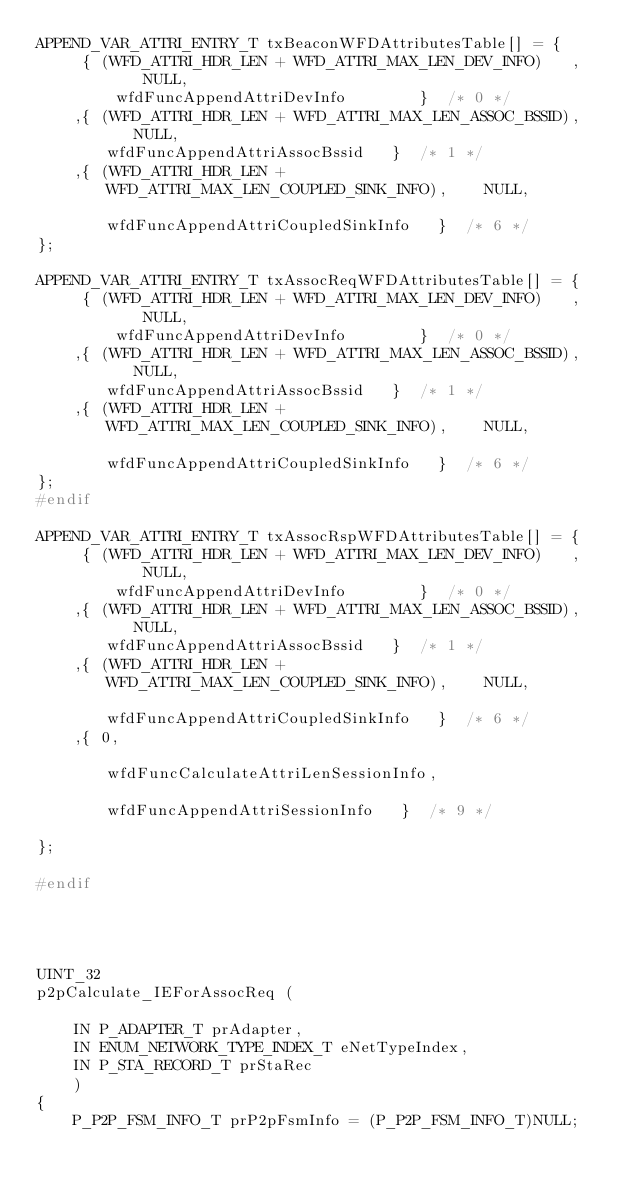<code> <loc_0><loc_0><loc_500><loc_500><_C_>APPEND_VAR_ATTRI_ENTRY_T txBeaconWFDAttributesTable[] = {
     { (WFD_ATTRI_HDR_LEN + WFD_ATTRI_MAX_LEN_DEV_INFO)   ,    NULL,                           wfdFuncAppendAttriDevInfo        }  /* 0 */
    ,{ (WFD_ATTRI_HDR_LEN + WFD_ATTRI_MAX_LEN_ASSOC_BSSID),    NULL,                           wfdFuncAppendAttriAssocBssid   }  /* 1 */
    ,{ (WFD_ATTRI_HDR_LEN + WFD_ATTRI_MAX_LEN_COUPLED_SINK_INFO),    NULL,                           wfdFuncAppendAttriCoupledSinkInfo   }  /* 6 */
};

APPEND_VAR_ATTRI_ENTRY_T txAssocReqWFDAttributesTable[] = {
     { (WFD_ATTRI_HDR_LEN + WFD_ATTRI_MAX_LEN_DEV_INFO)   ,    NULL,                           wfdFuncAppendAttriDevInfo        }  /* 0 */
    ,{ (WFD_ATTRI_HDR_LEN + WFD_ATTRI_MAX_LEN_ASSOC_BSSID),    NULL,                           wfdFuncAppendAttriAssocBssid   }  /* 1 */
    ,{ (WFD_ATTRI_HDR_LEN + WFD_ATTRI_MAX_LEN_COUPLED_SINK_INFO),    NULL,                           wfdFuncAppendAttriCoupledSinkInfo   }  /* 6 */
};
#endif

APPEND_VAR_ATTRI_ENTRY_T txAssocRspWFDAttributesTable[] = {
     { (WFD_ATTRI_HDR_LEN + WFD_ATTRI_MAX_LEN_DEV_INFO)   ,    NULL,                           wfdFuncAppendAttriDevInfo        }  /* 0 */
    ,{ (WFD_ATTRI_HDR_LEN + WFD_ATTRI_MAX_LEN_ASSOC_BSSID),    NULL,                           wfdFuncAppendAttriAssocBssid   }  /* 1 */
    ,{ (WFD_ATTRI_HDR_LEN + WFD_ATTRI_MAX_LEN_COUPLED_SINK_INFO),    NULL,                           wfdFuncAppendAttriCoupledSinkInfo   }  /* 6 */
    ,{ 0,                                                            wfdFuncCalculateAttriLenSessionInfo,                           wfdFuncAppendAttriSessionInfo   }  /* 9 */

};

#endif




UINT_32
p2pCalculate_IEForAssocReq (

    IN P_ADAPTER_T prAdapter,
    IN ENUM_NETWORK_TYPE_INDEX_T eNetTypeIndex,
    IN P_STA_RECORD_T prStaRec
    )
{
    P_P2P_FSM_INFO_T prP2pFsmInfo = (P_P2P_FSM_INFO_T)NULL;</code> 